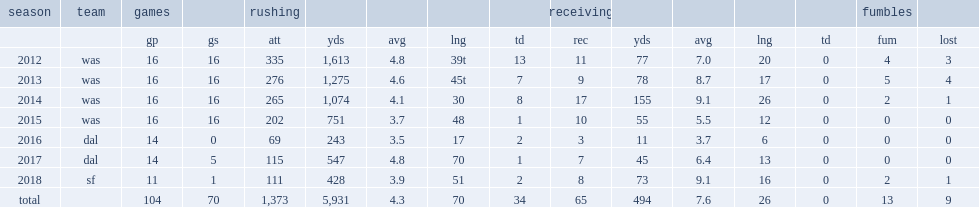In the 2018 regular season, how many rushing yards did alfred morris have? 111.0. What was the rushing yards that alfred morris got in 2018? 428.0. 